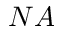Convert formula to latex. <formula><loc_0><loc_0><loc_500><loc_500>N A</formula> 